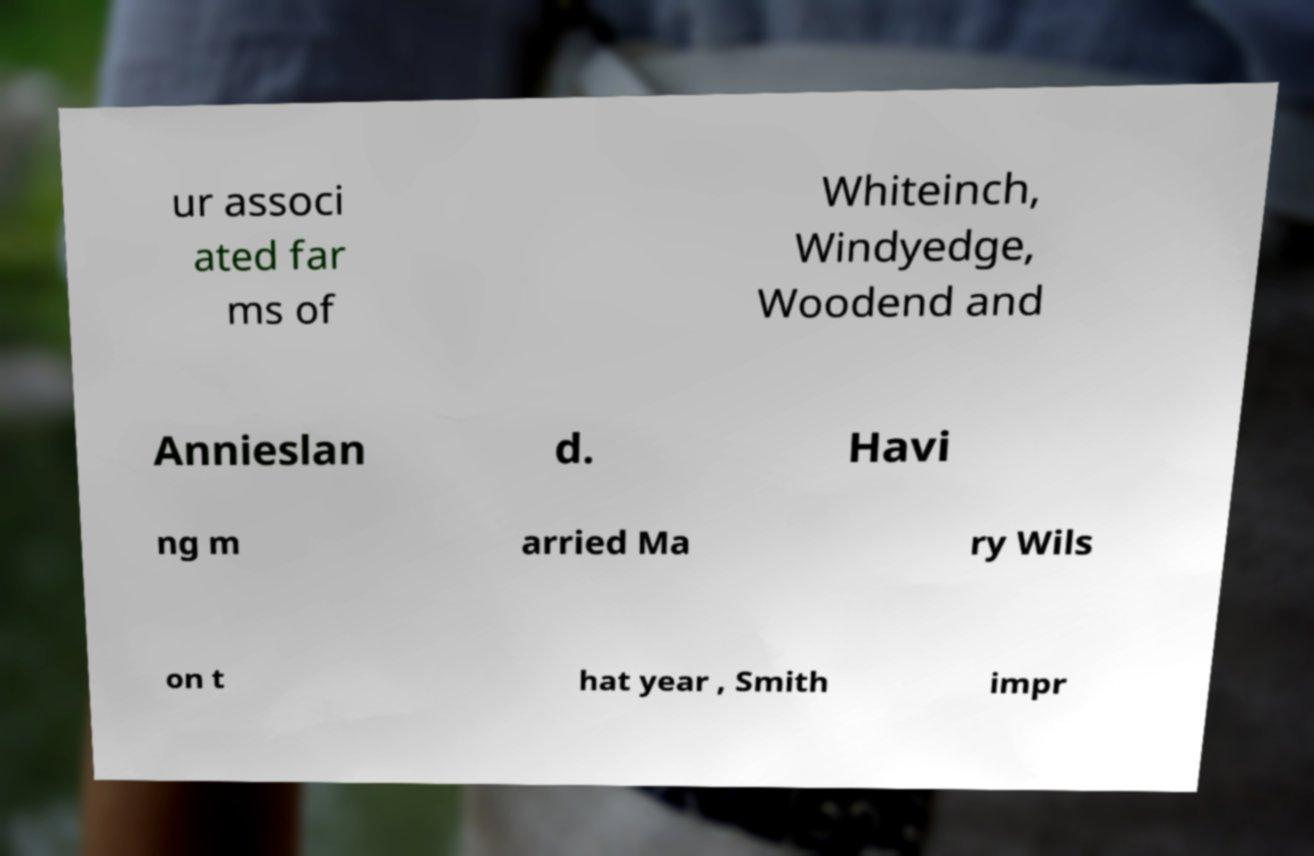Can you read and provide the text displayed in the image?This photo seems to have some interesting text. Can you extract and type it out for me? ur associ ated far ms of Whiteinch, Windyedge, Woodend and Annieslan d. Havi ng m arried Ma ry Wils on t hat year , Smith impr 